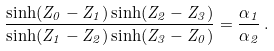<formula> <loc_0><loc_0><loc_500><loc_500>\frac { \sinh ( Z _ { 0 } - Z _ { 1 } ) \sinh ( Z _ { 2 } - Z _ { 3 } ) } { \sinh ( Z _ { 1 } - Z _ { 2 } ) \sinh ( Z _ { 3 } - Z _ { 0 } ) } = \frac { \alpha _ { 1 } } { \alpha _ { 2 } } \, .</formula> 